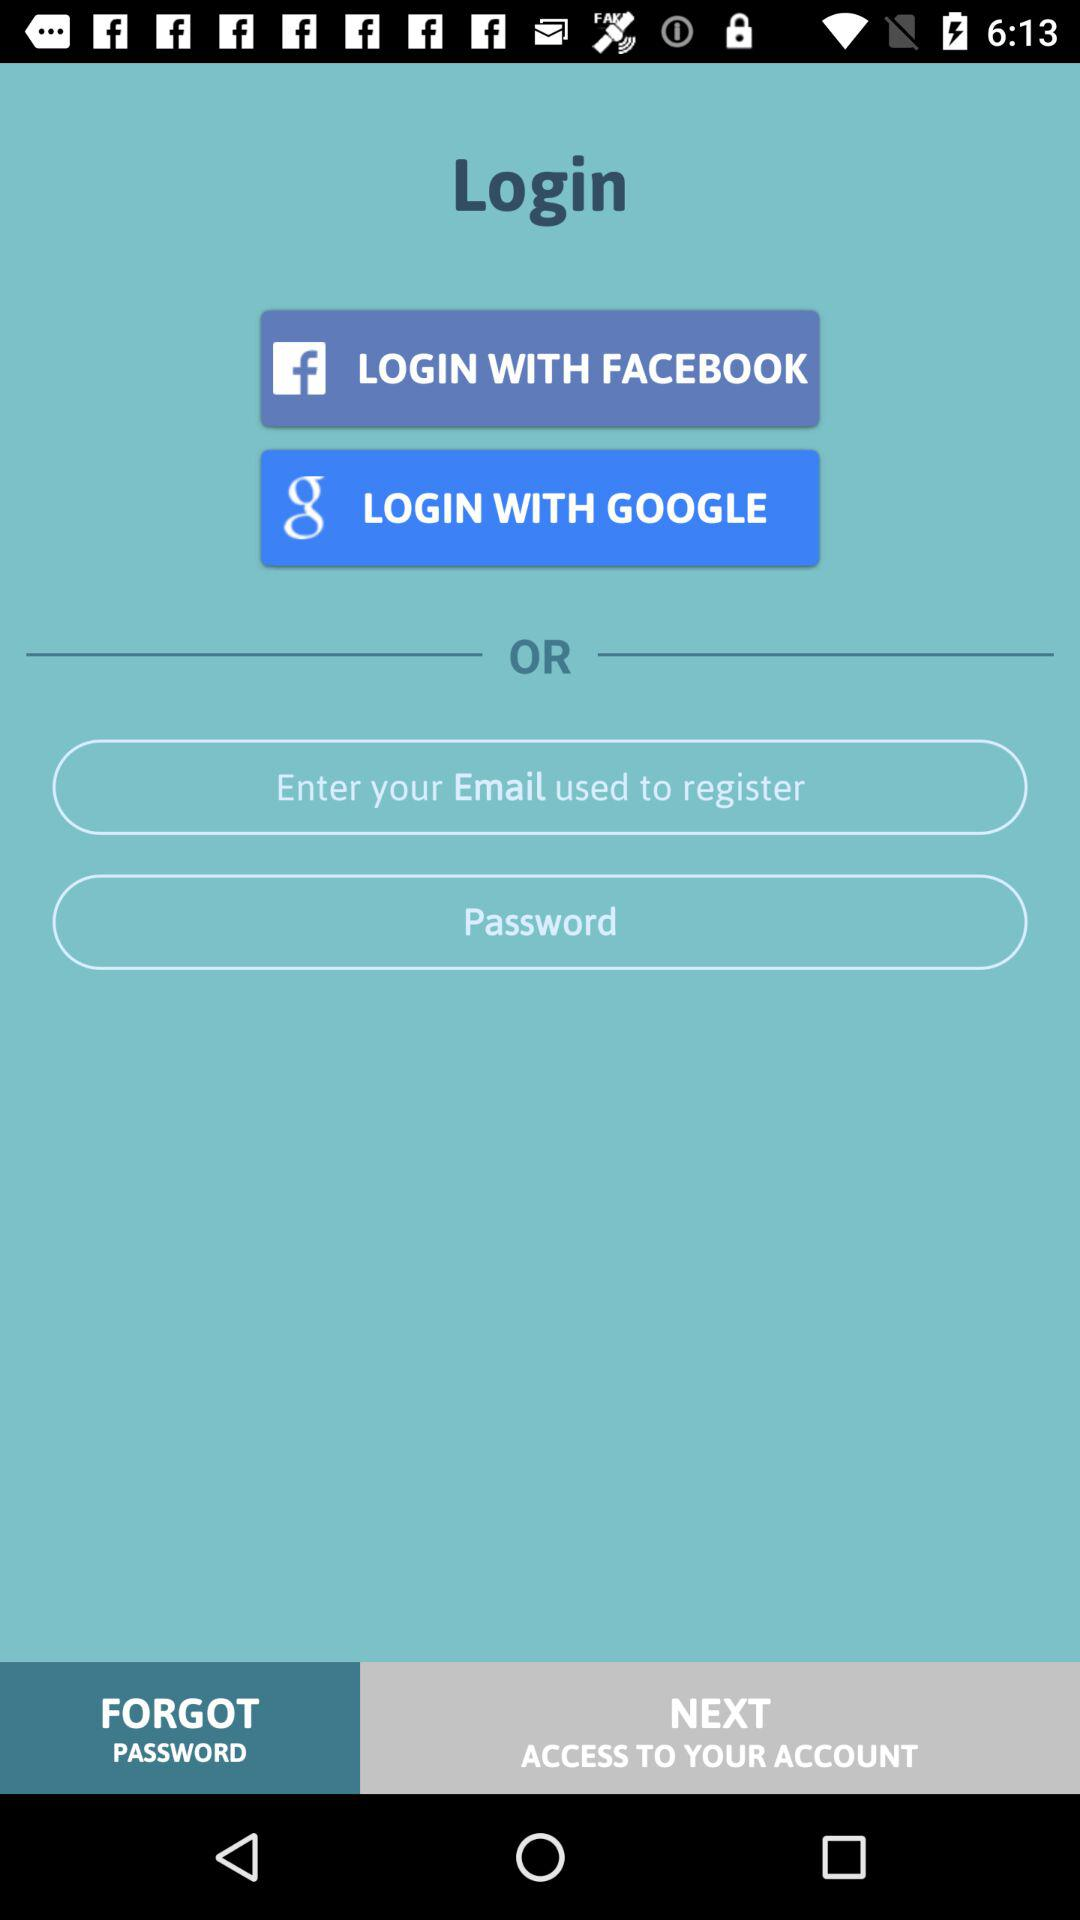What is the login option? The login options are "FACEBOOK", "GOOGLE" and "Email". 